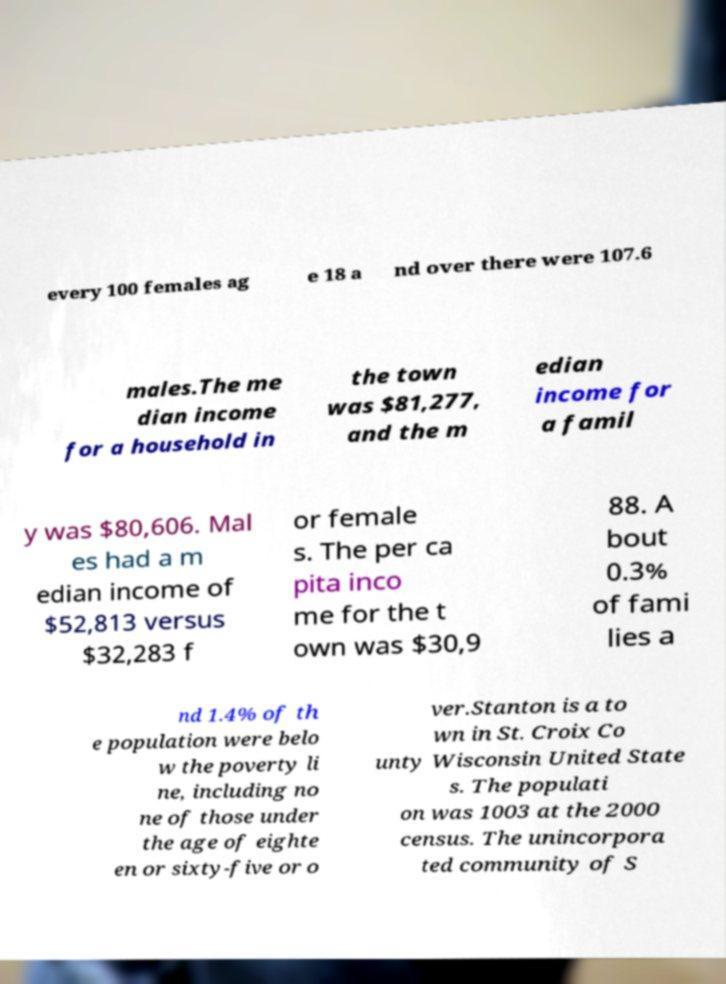For documentation purposes, I need the text within this image transcribed. Could you provide that? every 100 females ag e 18 a nd over there were 107.6 males.The me dian income for a household in the town was $81,277, and the m edian income for a famil y was $80,606. Mal es had a m edian income of $52,813 versus $32,283 f or female s. The per ca pita inco me for the t own was $30,9 88. A bout 0.3% of fami lies a nd 1.4% of th e population were belo w the poverty li ne, including no ne of those under the age of eighte en or sixty-five or o ver.Stanton is a to wn in St. Croix Co unty Wisconsin United State s. The populati on was 1003 at the 2000 census. The unincorpora ted community of S 